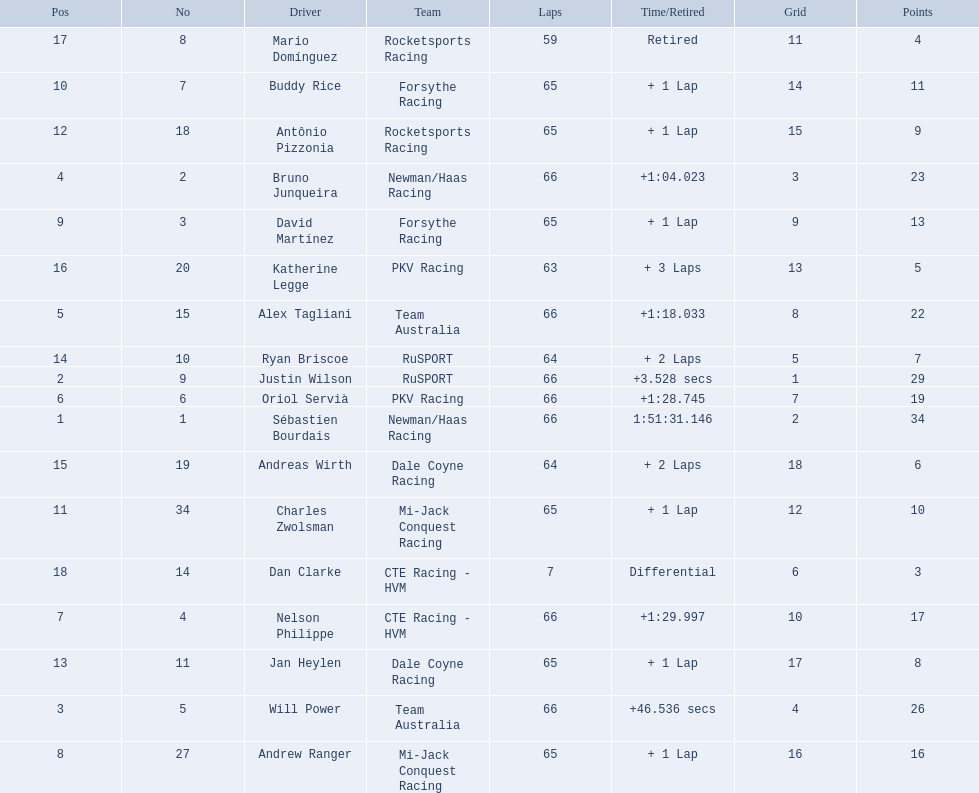Which people scored 29+ points? Sébastien Bourdais, Justin Wilson. Who scored higher? Sébastien Bourdais. 